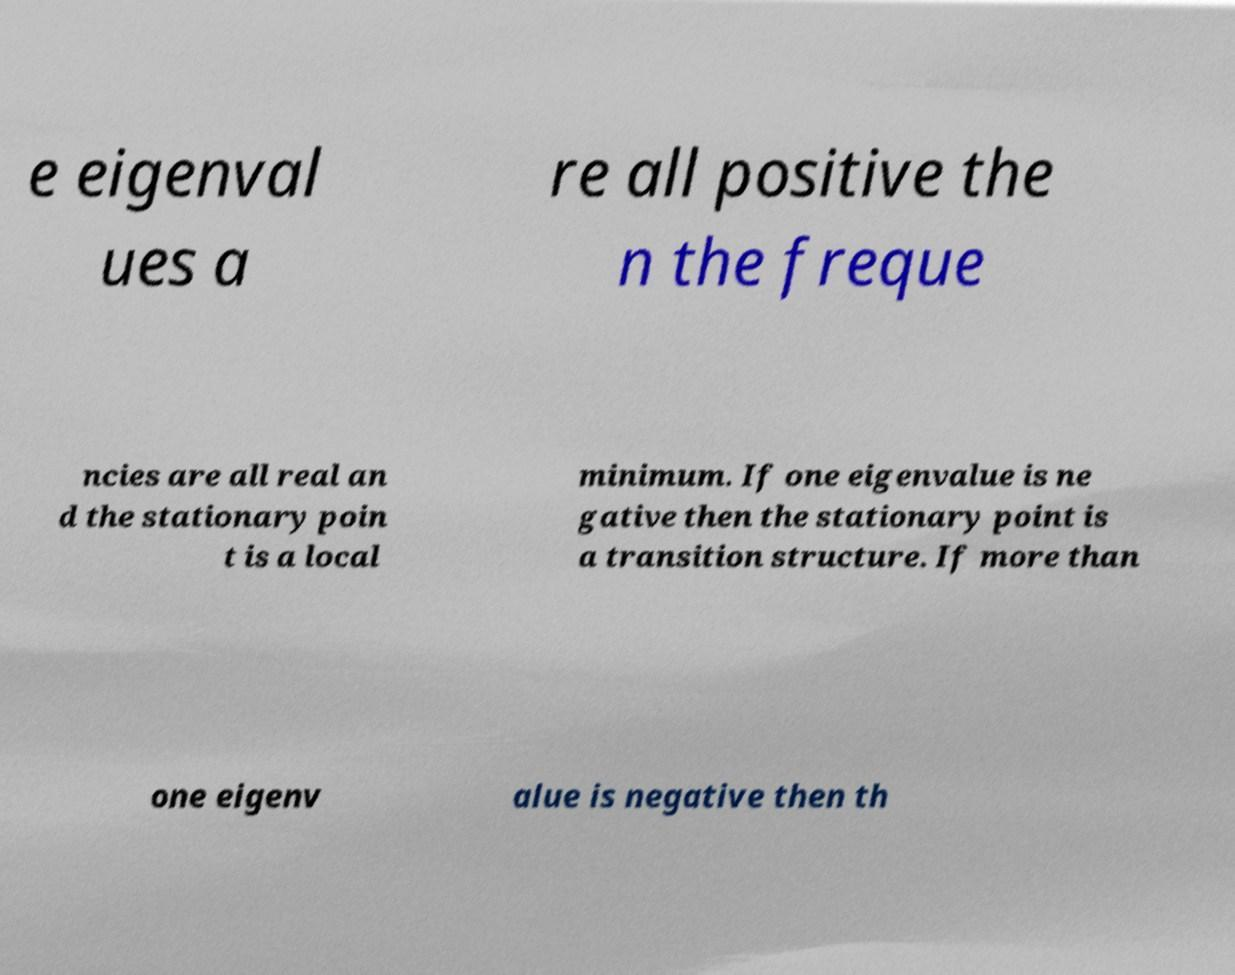For documentation purposes, I need the text within this image transcribed. Could you provide that? e eigenval ues a re all positive the n the freque ncies are all real an d the stationary poin t is a local minimum. If one eigenvalue is ne gative then the stationary point is a transition structure. If more than one eigenv alue is negative then th 